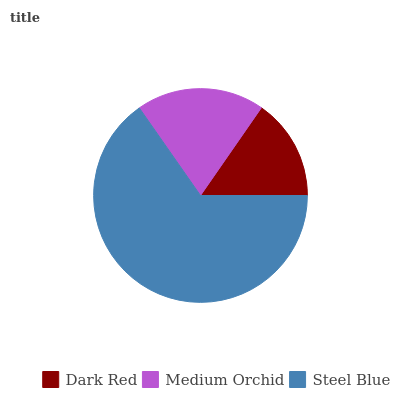Is Dark Red the minimum?
Answer yes or no. Yes. Is Steel Blue the maximum?
Answer yes or no. Yes. Is Medium Orchid the minimum?
Answer yes or no. No. Is Medium Orchid the maximum?
Answer yes or no. No. Is Medium Orchid greater than Dark Red?
Answer yes or no. Yes. Is Dark Red less than Medium Orchid?
Answer yes or no. Yes. Is Dark Red greater than Medium Orchid?
Answer yes or no. No. Is Medium Orchid less than Dark Red?
Answer yes or no. No. Is Medium Orchid the high median?
Answer yes or no. Yes. Is Medium Orchid the low median?
Answer yes or no. Yes. Is Steel Blue the high median?
Answer yes or no. No. Is Dark Red the low median?
Answer yes or no. No. 